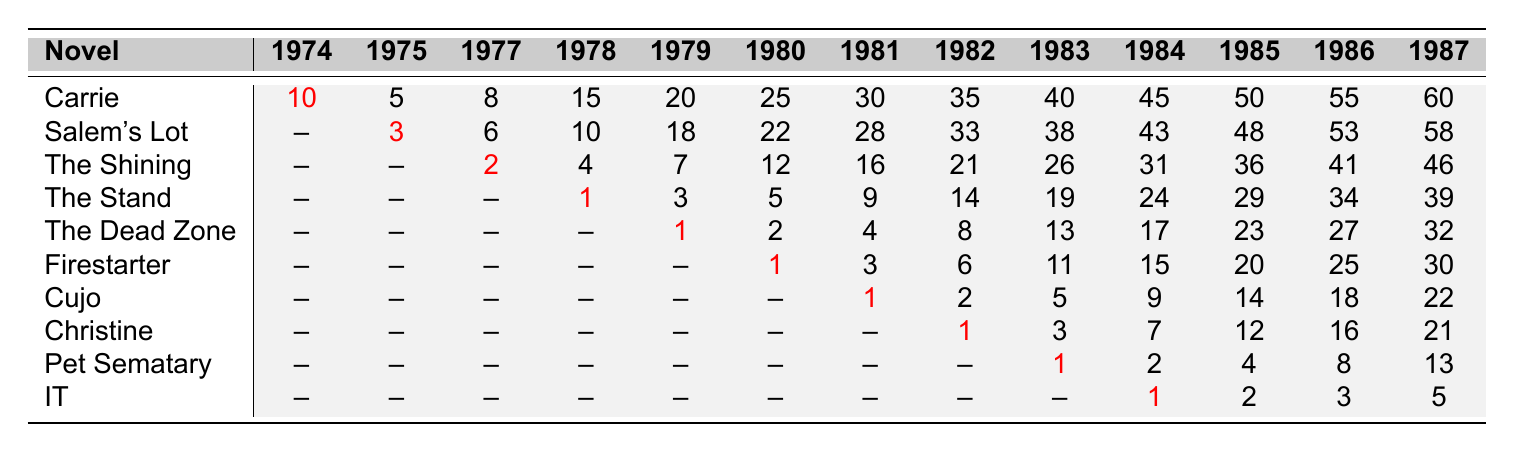What was the sales rank of "The Shining" in 1978? The sales rank of "The Shining" in 1978 is listed in the table under the year 1978, which shows a rank of 4.
Answer: 4 Which novel had the highest sales rank in 1975? According to the table, "Salem's Lot" had the highest sales rank in 1975 with a rank of 3.
Answer: Salem's Lot What is the average sales rank of "Firestarter" from 1980 to 1987? For "Firestarter", the sales ranks from 1980 to 1987 are [1, 3, 6, 11, 15, 20, 25, 30]. Adding these gives 111, and since there are 8 data points, the average is 111/8 = 13.875.
Answer: 13.875 Did "Cujo" ever achieve a rank in the top 5 during the years shown? By examining the ranks for "Cujo," it achieves a rank of 1 in 1981, which is within the top 5. Therefore, the answer is yes.
Answer: Yes Which novel consistently improved its sales rank over the years? Reviewing the ranks of each novel, "The Stand" shows a consistent improvement from rank 1 in 1978 to rank 39 in 1987, indicating a consistent upward trend in ranks.
Answer: The Stand What is the difference in sales rank for "Christine" between 1982 and 1987? The sales rank for "Christine" in 1982 is 1 and in 1987 is 21. The difference is calculated as 21 - 1 = 20.
Answer: 20 In which year did "The Dead Zone" first achieve a sales rank of 1? The table shows that "The Dead Zone" first achieved a rank of 1 in 1979.
Answer: 1979 Which novel had the most years listed with a sales rank of null? By reviewing the table, "IT" has all ranks as null except for the year 1984 and beyond. It has 8 years listed as null, making it the novel with the most null ranks.
Answer: IT If you sum the sales ranks of "Carrie" from 1974 to 1987, what is the total? The sales ranks of "Carrie" for the years are [10, 5, 8, 15, 20, 25, 30, 35, 40, 45, 50, 55, 60]. Summing these gives 513 (10 + 5 + 8 + 15 + 20 + 25 + 30 + 35 + 40 + 45 + 50 + 55 + 60).
Answer: 513 Which novel had the worst sales rank in 1985? In 1985, the ranks for each novel are compared, and "Christine" had the lowest rank of 12.
Answer: Christine 